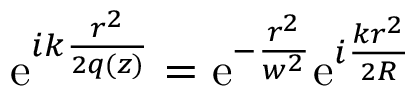<formula> <loc_0><loc_0><loc_500><loc_500>\begin{array} { r } { e ^ { i k \frac { r ^ { 2 } } { 2 q ( z ) } } = e ^ { - \frac { r ^ { 2 } } { w ^ { 2 } } } e ^ { i \frac { k r ^ { 2 } } { 2 R } } } \end{array}</formula> 